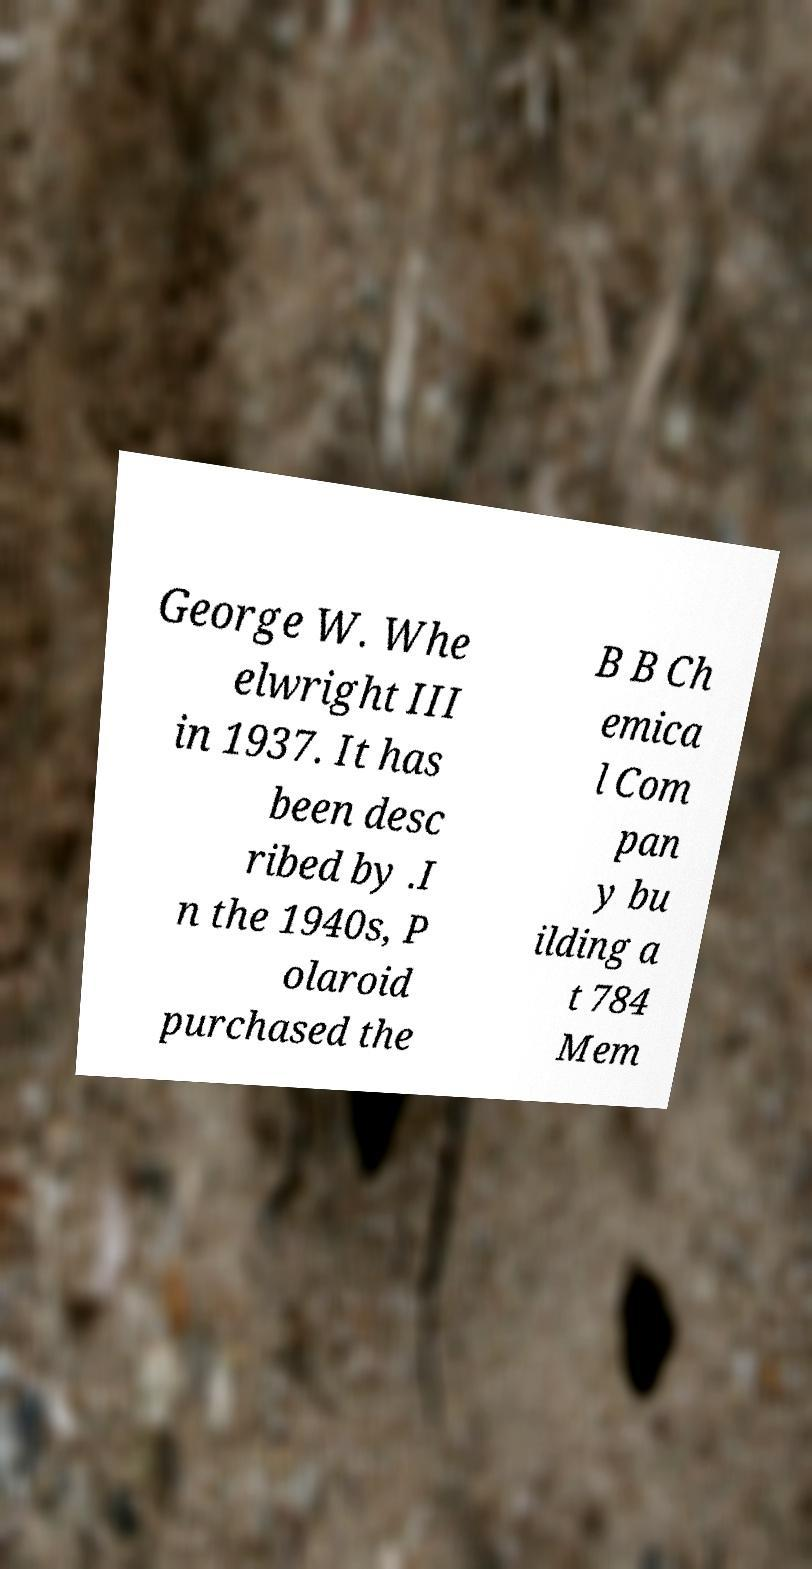Could you extract and type out the text from this image? George W. Whe elwright III in 1937. It has been desc ribed by .I n the 1940s, P olaroid purchased the B B Ch emica l Com pan y bu ilding a t 784 Mem 